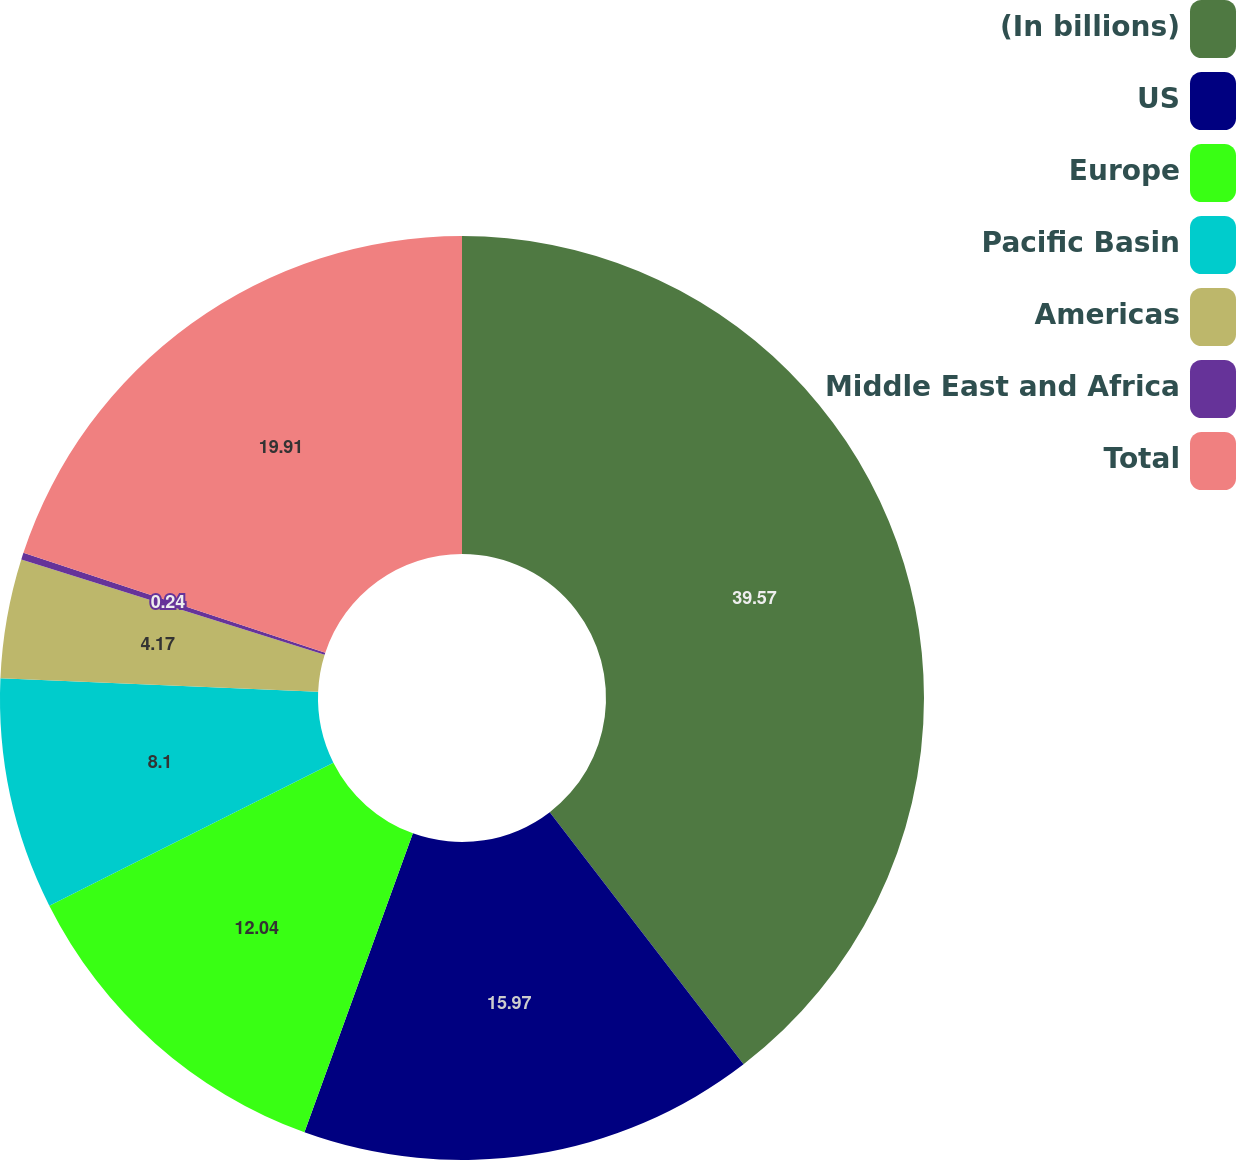Convert chart to OTSL. <chart><loc_0><loc_0><loc_500><loc_500><pie_chart><fcel>(In billions)<fcel>US<fcel>Europe<fcel>Pacific Basin<fcel>Americas<fcel>Middle East and Africa<fcel>Total<nl><fcel>39.57%<fcel>15.97%<fcel>12.04%<fcel>8.1%<fcel>4.17%<fcel>0.24%<fcel>19.91%<nl></chart> 